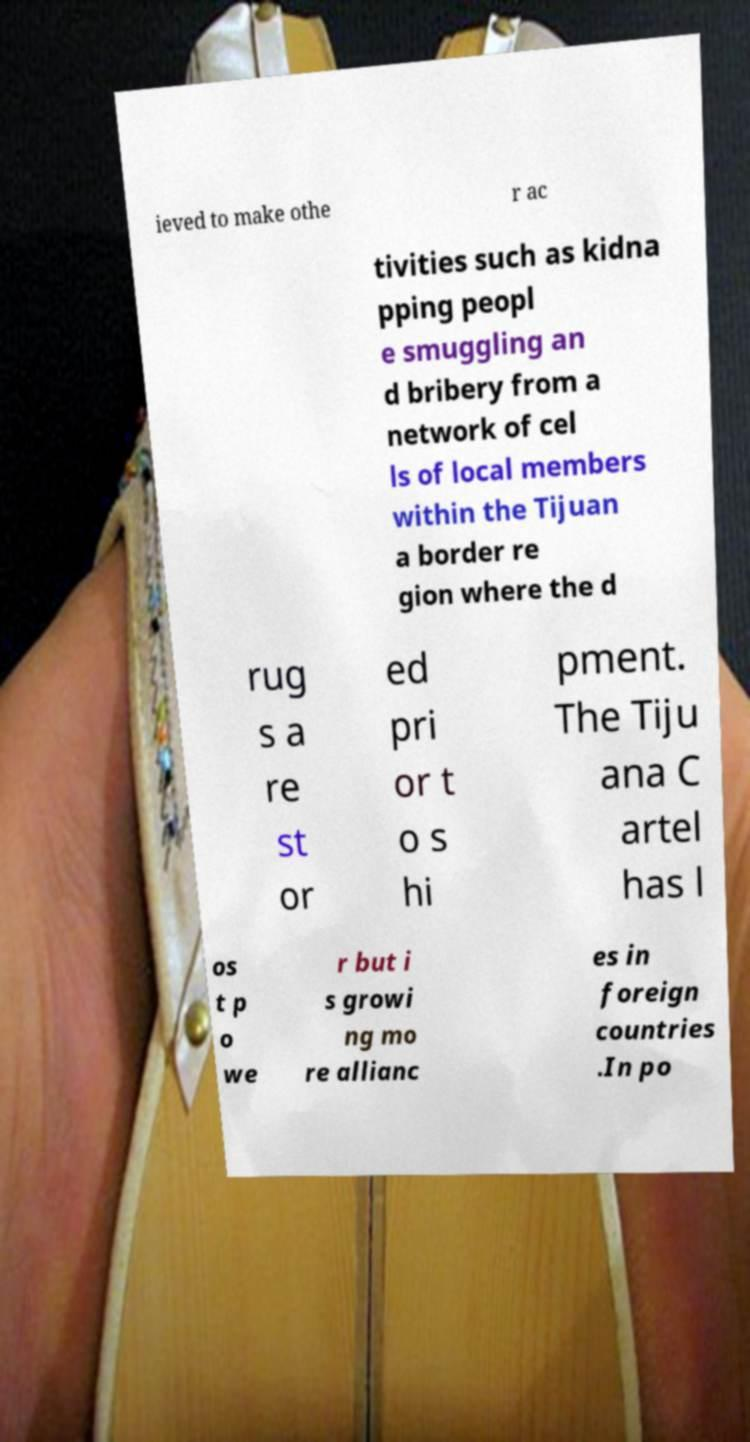There's text embedded in this image that I need extracted. Can you transcribe it verbatim? ieved to make othe r ac tivities such as kidna pping peopl e smuggling an d bribery from a network of cel ls of local members within the Tijuan a border re gion where the d rug s a re st or ed pri or t o s hi pment. The Tiju ana C artel has l os t p o we r but i s growi ng mo re allianc es in foreign countries .In po 